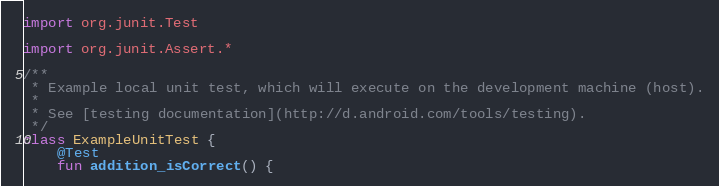<code> <loc_0><loc_0><loc_500><loc_500><_Kotlin_>import org.junit.Test

import org.junit.Assert.*

/**
 * Example local unit test, which will execute on the development machine (host).
 *
 * See [testing documentation](http://d.android.com/tools/testing).
 */
class ExampleUnitTest {
    @Test
    fun addition_isCorrect() {</code> 